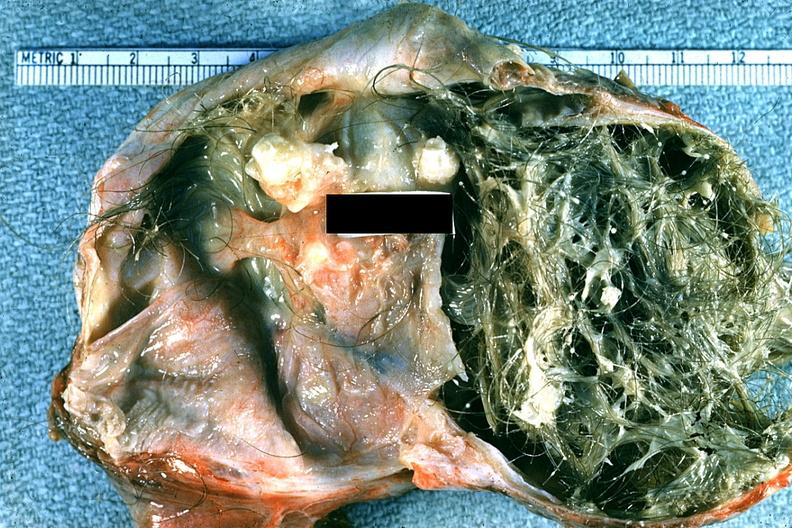what does this image show?
Answer the question using a single word or phrase. Good example typical dermoid with hair and sebaceous material 